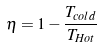Convert formula to latex. <formula><loc_0><loc_0><loc_500><loc_500>\eta = 1 - \frac { T _ { c o l d } } { T _ { H o t } }</formula> 